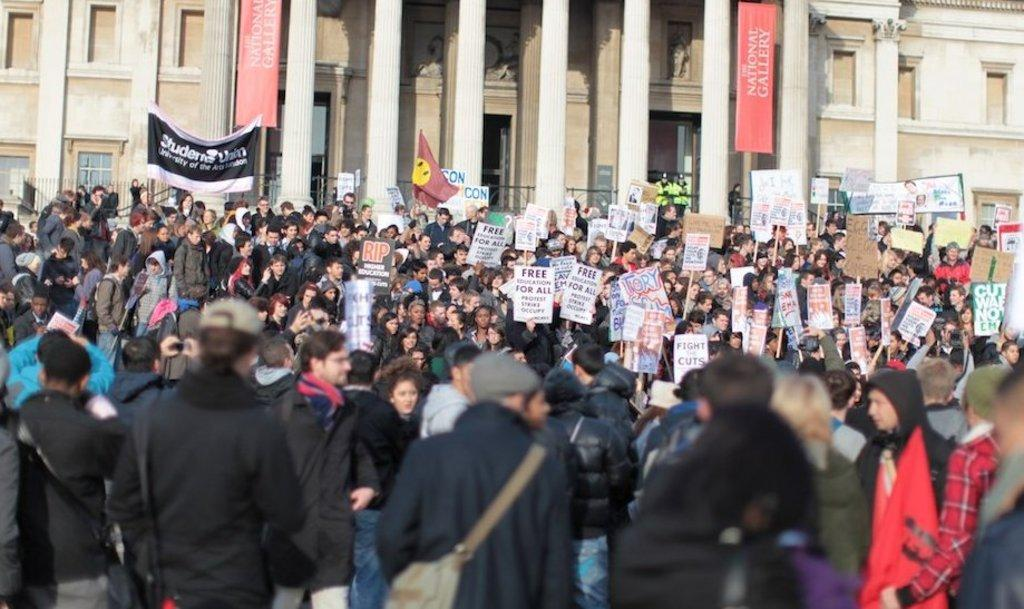How many people are present in the image? There are many people in the image. What are the people holding in the image? The people are holding boards with text. Are there any other text-related items in the image? Yes, there are banners with text in the image. What type of structure can be seen in the image? There is a building in the image. What type of plants are being used as partners in the image? There are no plants or partners present in the image. How many balls are visible in the image? There are no balls visible in the image. 